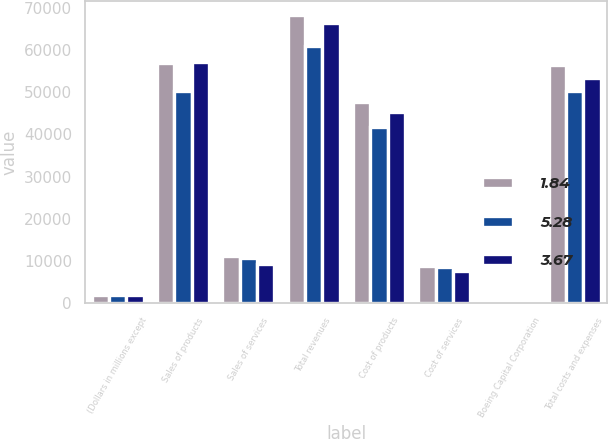Convert chart. <chart><loc_0><loc_0><loc_500><loc_500><stacked_bar_chart><ecel><fcel>(Dollars in millions except<fcel>Sales of products<fcel>Sales of services<fcel>Total revenues<fcel>Cost of products<fcel>Cost of services<fcel>Boeing Capital Corporation<fcel>Total costs and expenses<nl><fcel>1.84<fcel>2009<fcel>57032<fcel>11249<fcel>68281<fcel>47639<fcel>8726<fcel>175<fcel>56540<nl><fcel>5.28<fcel>2008<fcel>50180<fcel>10729<fcel>60909<fcel>41662<fcel>8467<fcel>223<fcel>50352<nl><fcel>3.67<fcel>2007<fcel>57049<fcel>9338<fcel>66387<fcel>45375<fcel>7732<fcel>295<fcel>53402<nl></chart> 